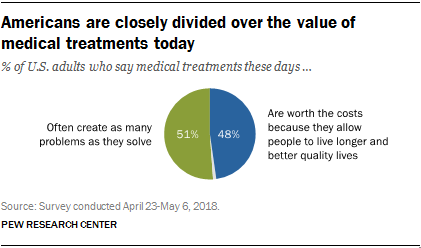Identify some key points in this picture. The ratio of the two largest segments (A and B) is 0.678472222... The color of the largest segment is not blue. 